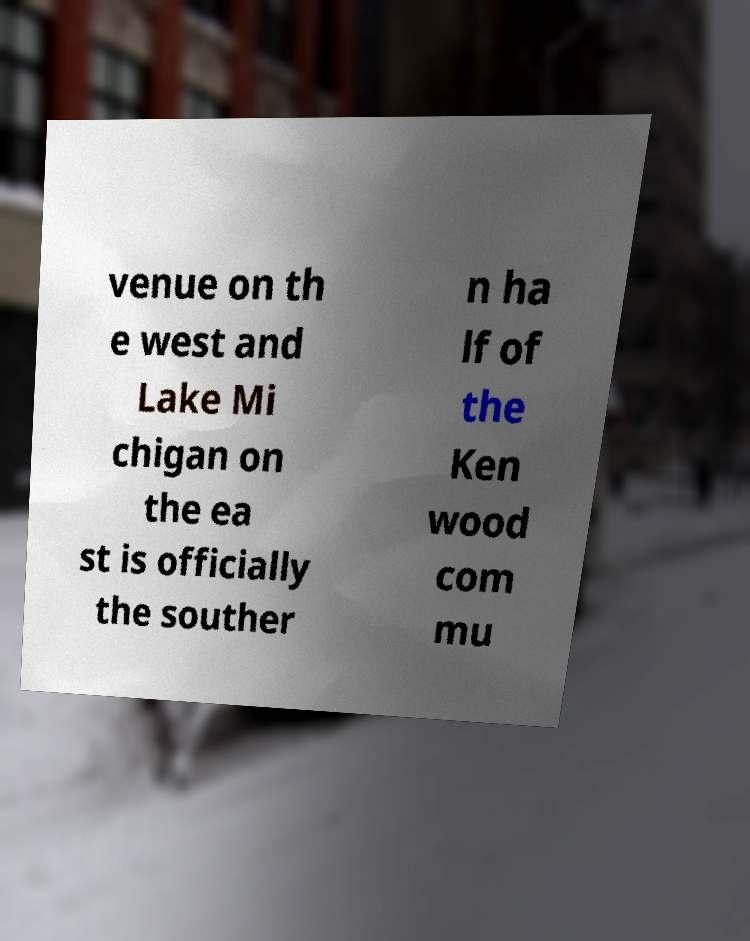Could you assist in decoding the text presented in this image and type it out clearly? venue on th e west and Lake Mi chigan on the ea st is officially the souther n ha lf of the Ken wood com mu 